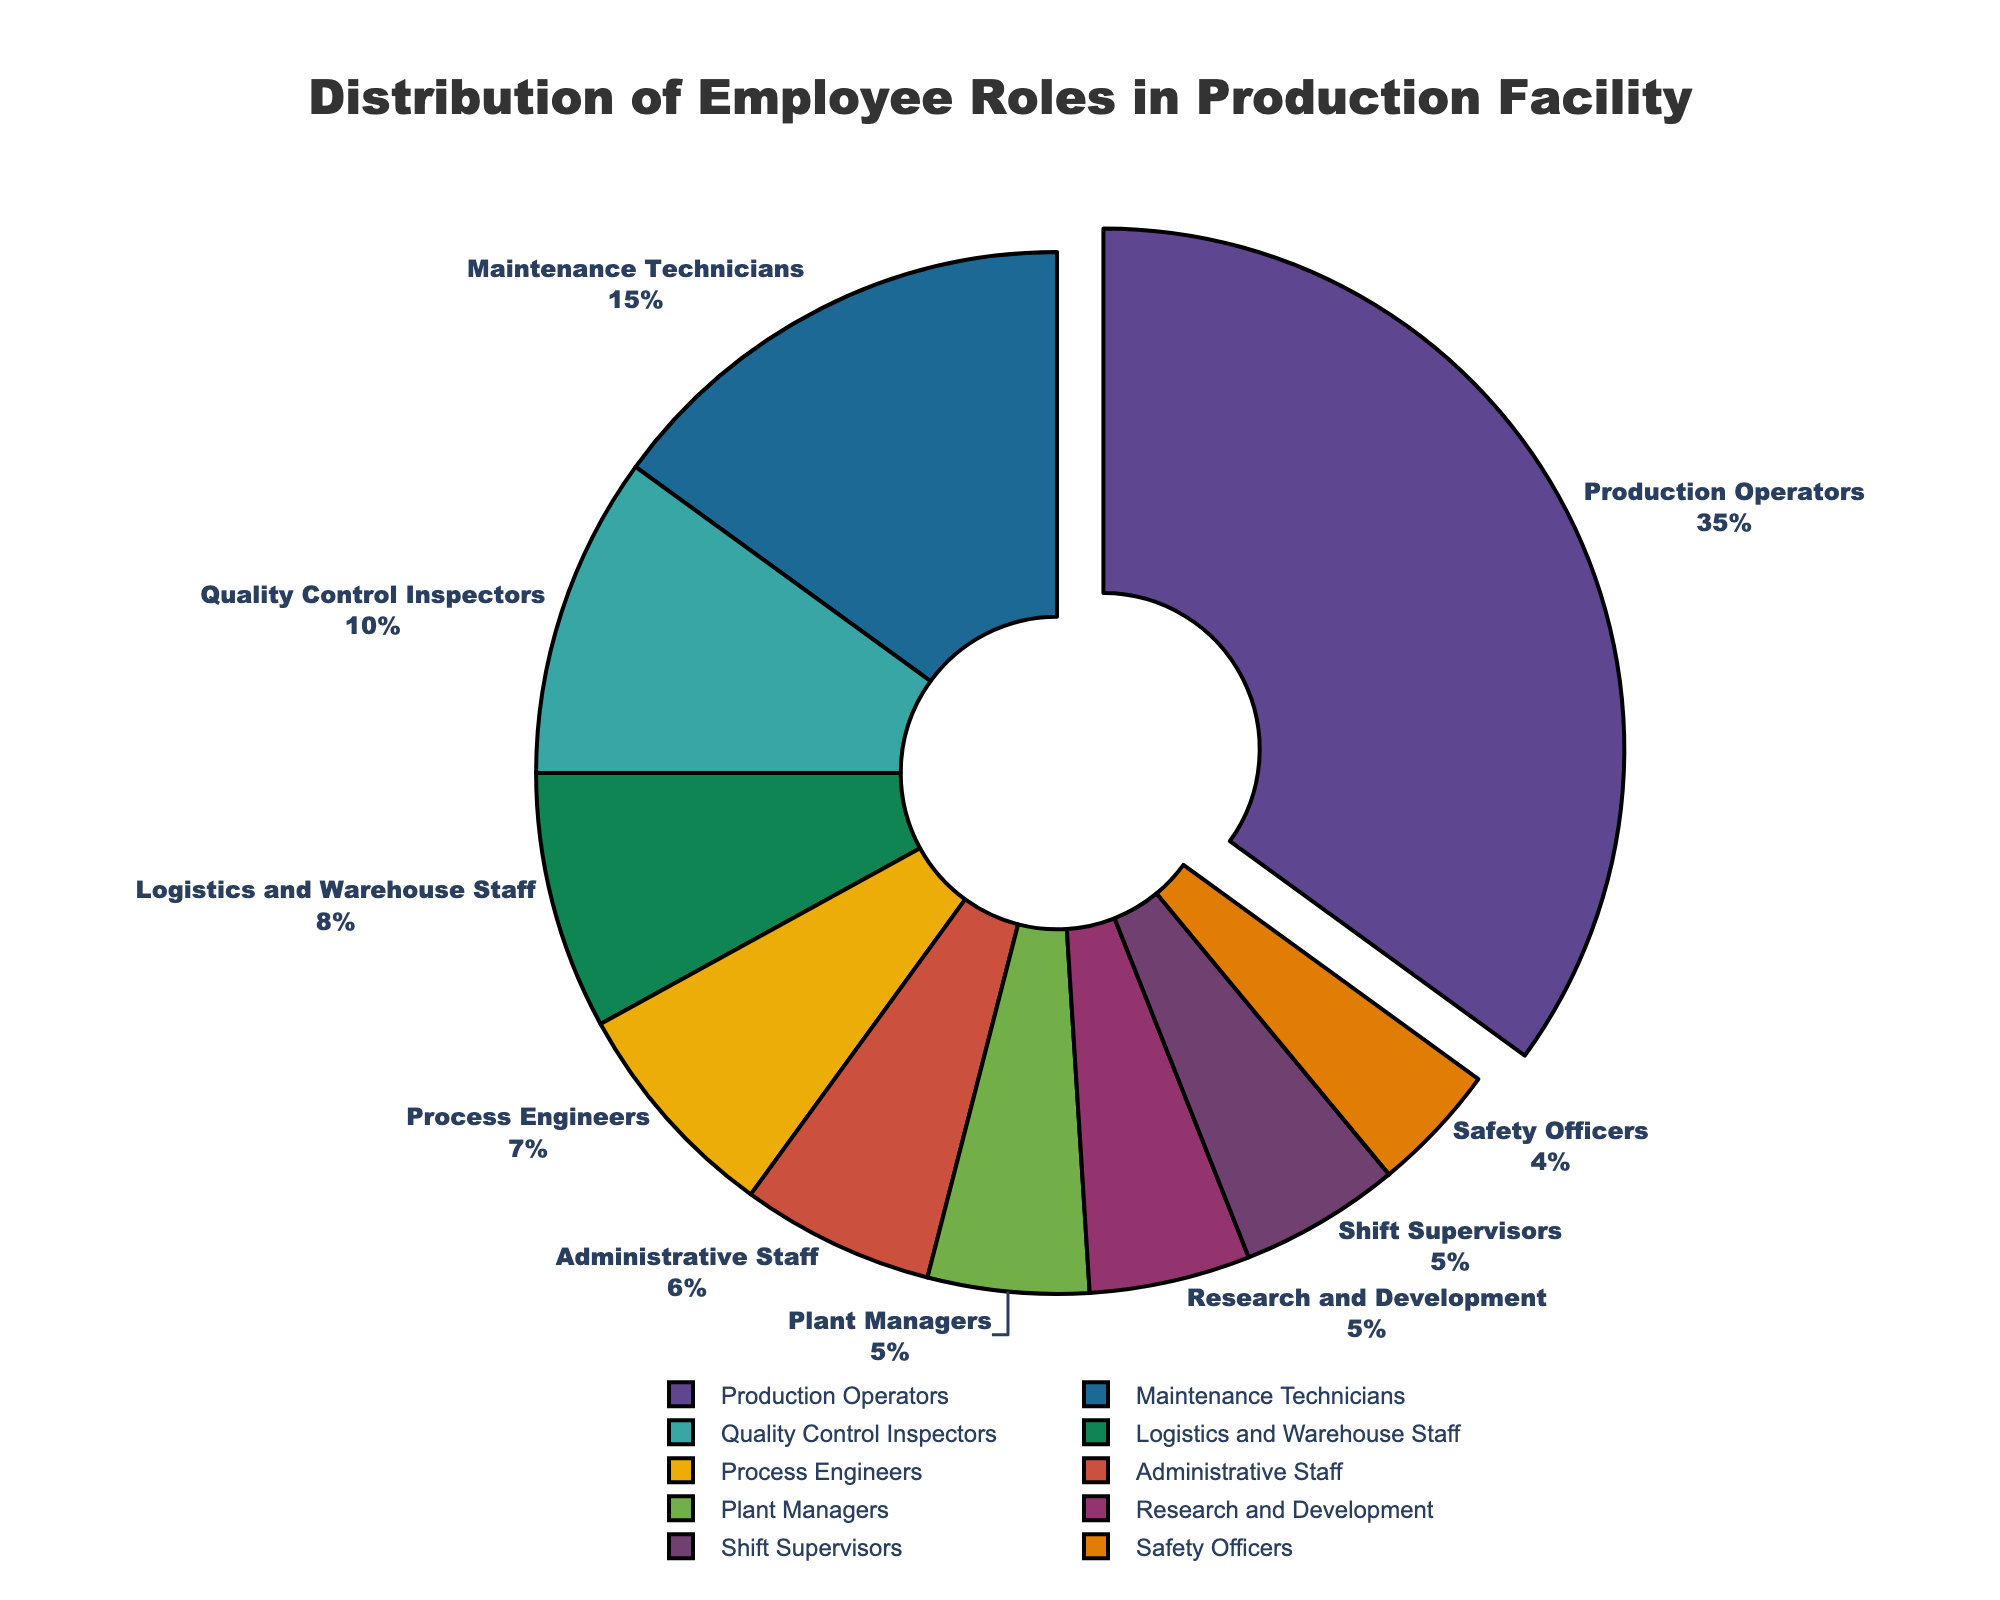What's the largest employee role by percentage? The figure highlights the largest segment (pulled-out slice) which corresponds to "Production Operators." According to the data, the largest percentage is 35%, assigned to Production Operators.
Answer: Production Operators Which employee roles each constitute 5% of the total distribution? The pie chart shows labels and percentages for each segment. Employee roles with 5% are "Plant Managers," "Research and Development," and "Shift Supervisors."
Answer: Plant Managers, Research and Development, Shift Supervisors How much more percentage do Production Operators contribute compared to Maintenance Technicians? Production Operators contribute 35%, and Maintenance Technicians contribute 15%. The difference is calculated as 35% - 15% = 20%.
Answer: 20% Which section has the smallest portion on the pie chart? The smallest portion of the pie chart corresponds to the section labeled "Safety Officers" with a percentage of 4%.
Answer: Safety Officers What is the total percentage contribution of administrative and logistics staff combined? Administrative Staff contributes 6% and Logistics and Warehouse Staff contribute 8%. The combined contribution is 6% + 8% = 14%.
Answer: 14% Are there more Maintenance Technicians or Process Engineers, and by how much? Maintenance Technicians account for 15% and Process Engineers account for 7%. The difference is 15% - 7% = 8%.
Answer: Maintenance Technicians, by 8% If you add Maintenance Technicians and Safety Officers, what is their combined percentage? Maintenance Technicians account for 15%, and Safety Officers account for 4%. Adding them together gives 15% + 4% = 19%.
Answer: 19% Rank the roles by decreasing percentage. From the pie chart, the roles ranked by decreasing percentage are: Production Operators (35%), Maintenance Technicians (15%), Quality Control Inspectors (10%), Logistics and Warehouse Staff (8%), Process Engineers (7%), Administrative Staff (6%), Plant Managers (5%), Research and Development (5%), Shift Supervisors (5%), Safety Officers (4%).
Answer: Production Operators > Maintenance Technicians > Quality Control Inspectors > Logistics and Warehouse Staff > Process Engineers > Administrative Staff > Plant Managers > Research and Development > Shift Supervisors > Safety Officers Which role is visually represented by the color that appears next to Production Operators' slice? Based on the color sequence and pie chart's clockwise representation, the section adjacent to Production Operators' slice (presumably in the Prism color palette) is Maintenance Technicians.
Answer: Maintenance Technicians 